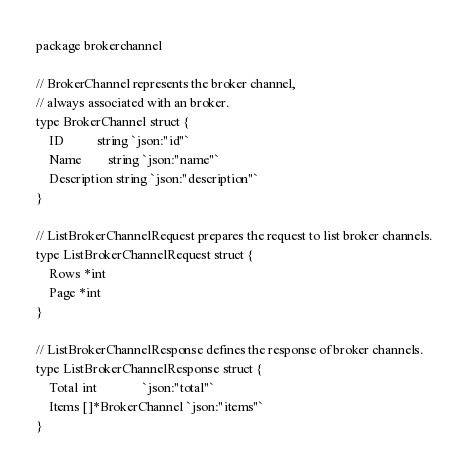<code> <loc_0><loc_0><loc_500><loc_500><_Go_>package brokerchannel

// BrokerChannel represents the broker channel,
// always associated with an broker.
type BrokerChannel struct {
	ID          string `json:"id"`
	Name        string `json:"name"`
	Description string `json:"description"`
}

// ListBrokerChannelRequest prepares the request to list broker channels.
type ListBrokerChannelRequest struct {
	Rows *int
	Page *int
}

// ListBrokerChannelResponse defines the response of broker channels.
type ListBrokerChannelResponse struct {
	Total int              `json:"total"`
	Items []*BrokerChannel `json:"items"`
}
</code> 